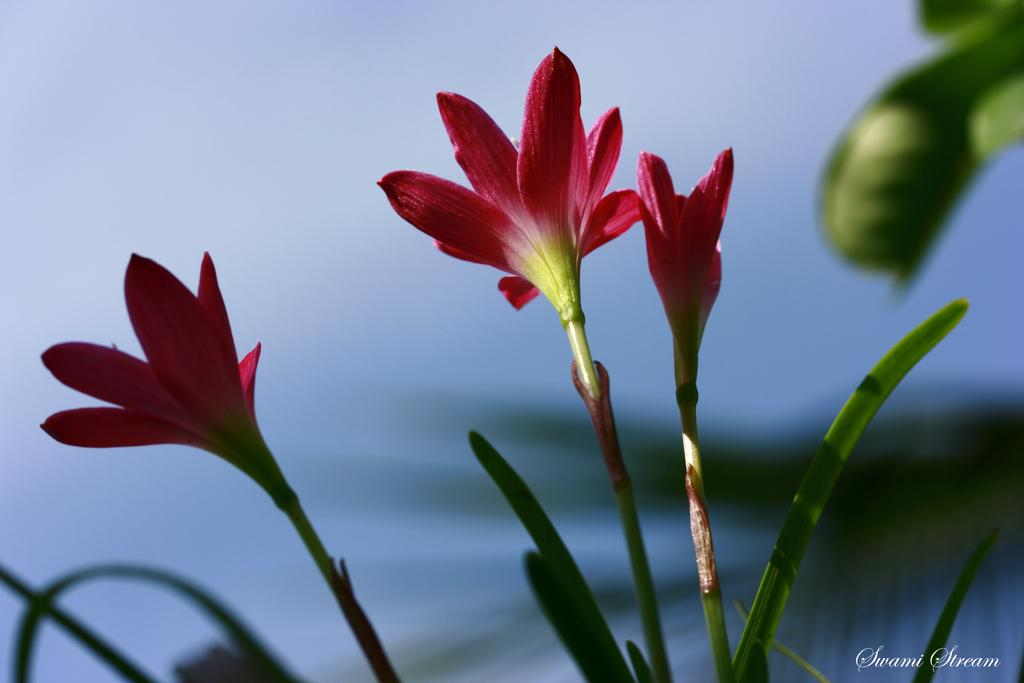What type of flowers are visible in the image? There are pink flowers in the image. Where are the flowers located? The flowers are on a plant. What can be observed about the background of the flowers? The background of the flowers is blurred. How much debt is the robin in the image carrying? There is no robin present in the image, and therefore no debt can be associated with it. 